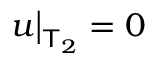<formula> <loc_0><loc_0><loc_500><loc_500>u \Big | _ { \mathsf T _ { 2 } } = 0</formula> 